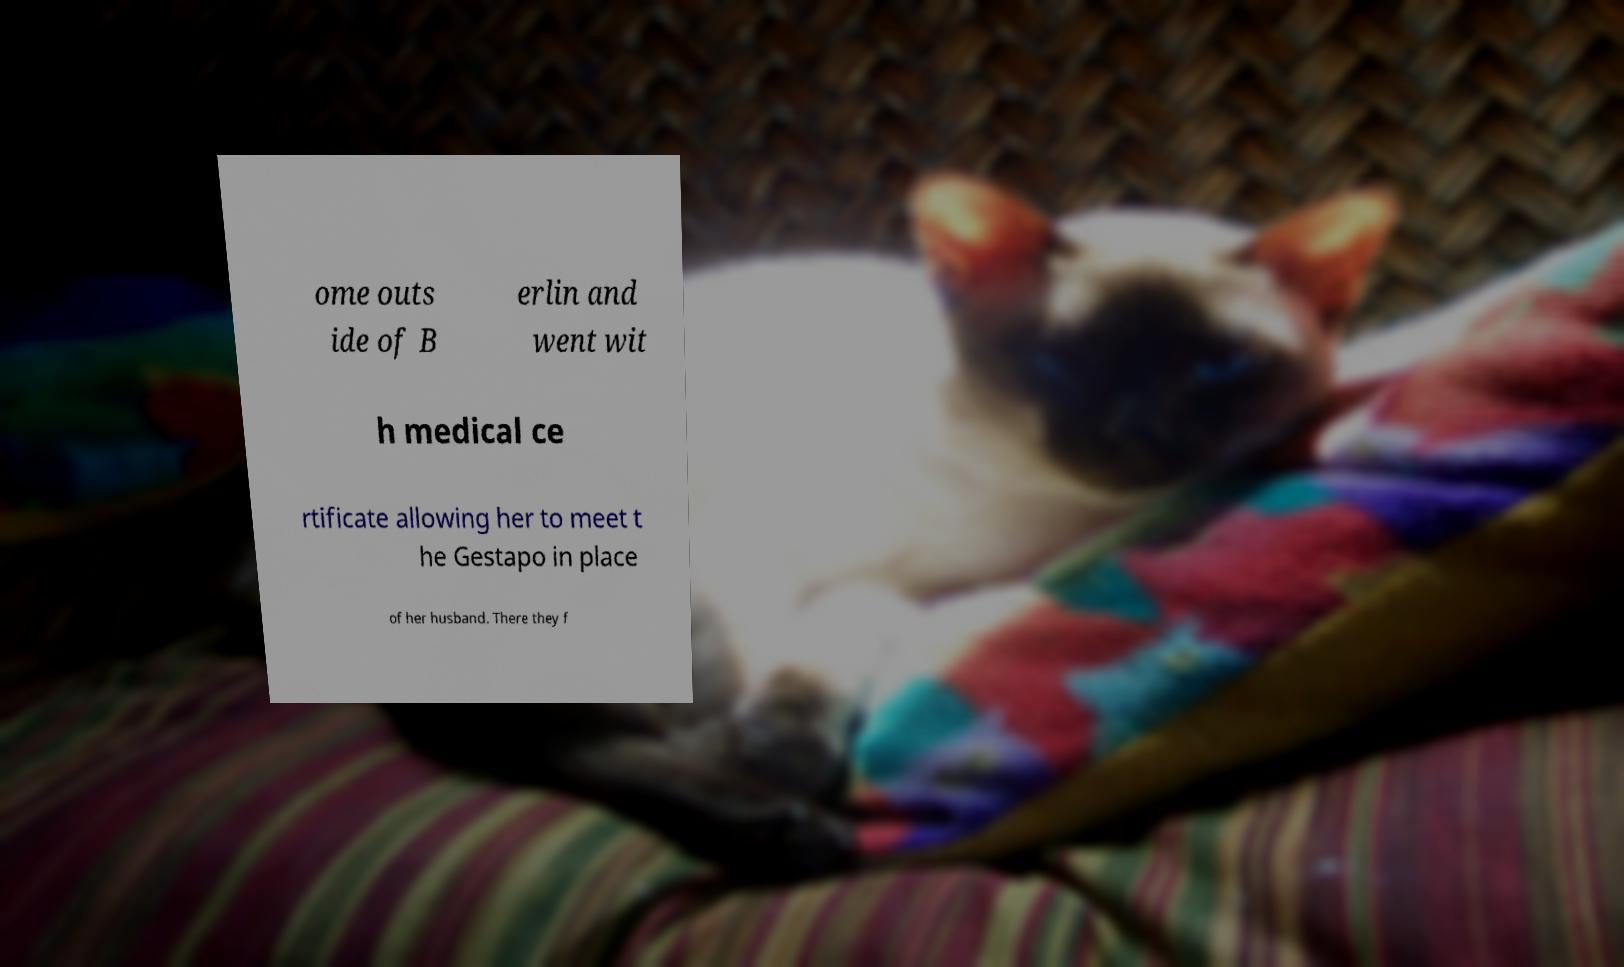I need the written content from this picture converted into text. Can you do that? ome outs ide of B erlin and went wit h medical ce rtificate allowing her to meet t he Gestapo in place of her husband. There they f 